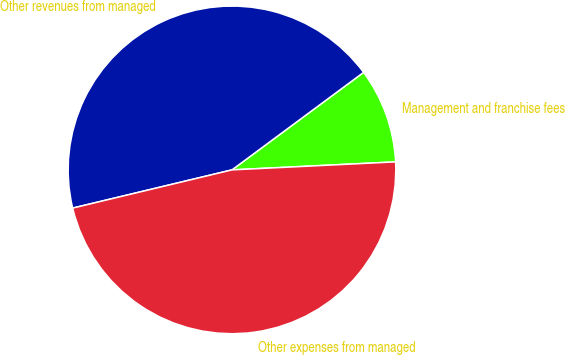Convert chart to OTSL. <chart><loc_0><loc_0><loc_500><loc_500><pie_chart><fcel>Management and franchise fees<fcel>Other revenues from managed<fcel>Other expenses from managed<nl><fcel>9.37%<fcel>43.6%<fcel>47.03%<nl></chart> 